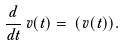<formula> <loc_0><loc_0><loc_500><loc_500>\frac { d } { d t } \, v ( t ) = \, \Phi ( v ( t ) ) .</formula> 